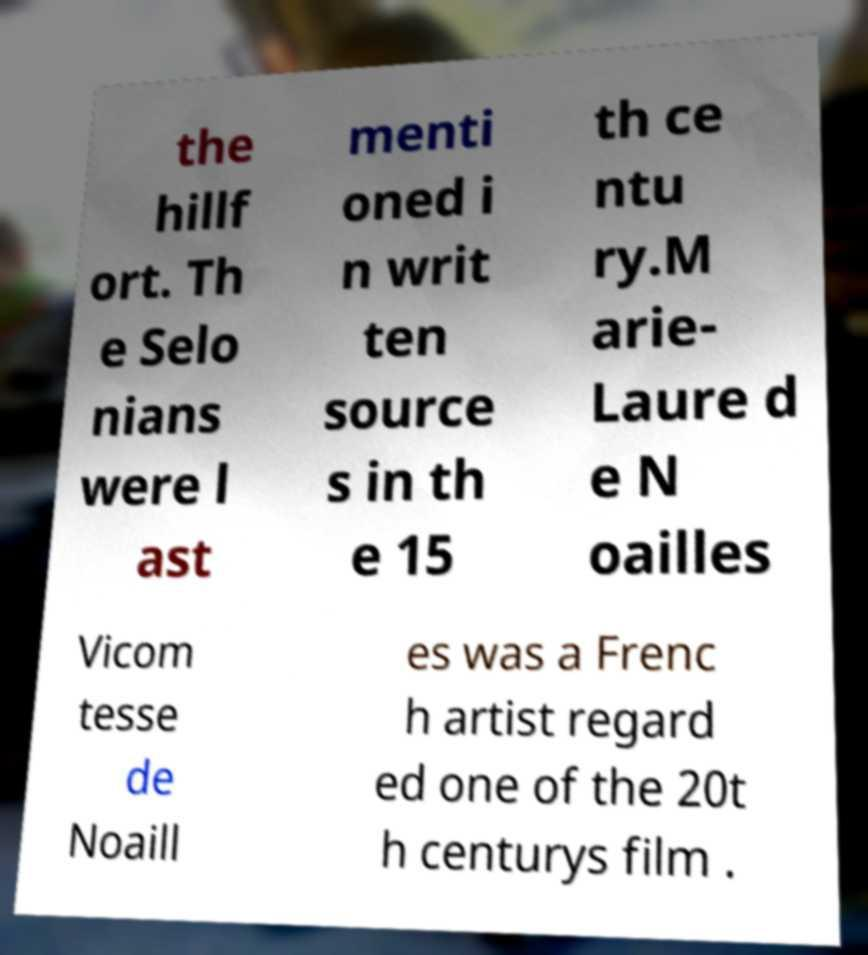I need the written content from this picture converted into text. Can you do that? the hillf ort. Th e Selo nians were l ast menti oned i n writ ten source s in th e 15 th ce ntu ry.M arie- Laure d e N oailles Vicom tesse de Noaill es was a Frenc h artist regard ed one of the 20t h centurys film . 